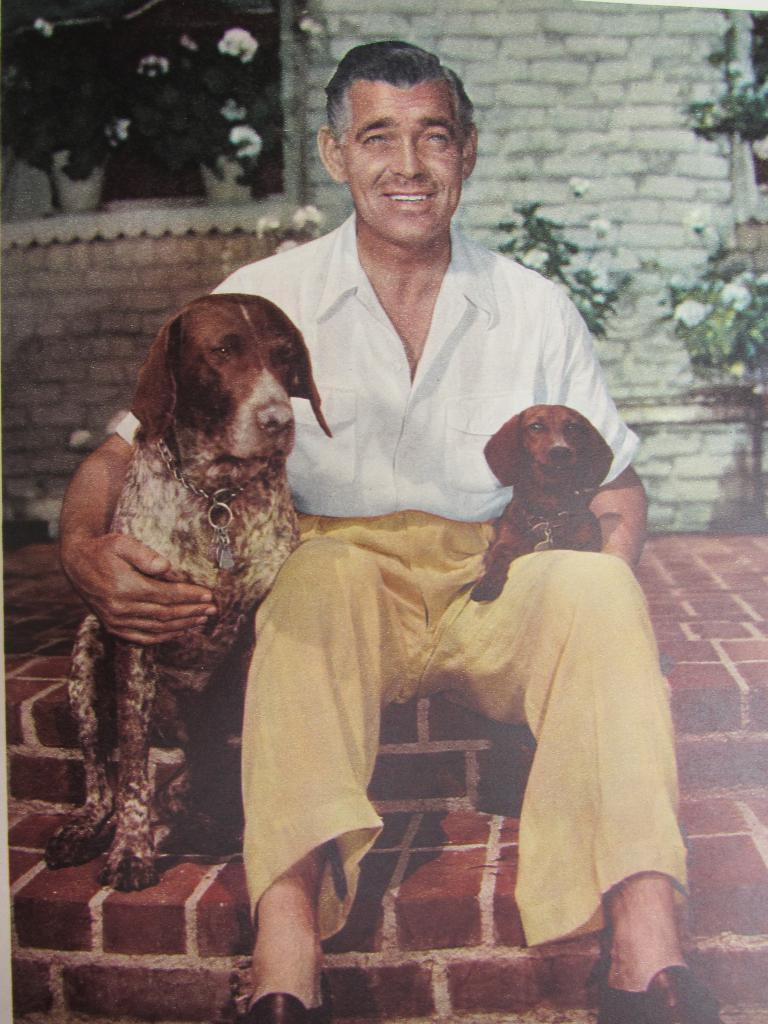What is the man in the image doing? The man is sitting in the image. What is the man holding in the image? The man is holding two dogs, one on each side. What is located behind the man in the image? There is a wall behind the man. What type of vegetation can be seen in the image? There are plants visible in the image. What type of vessel is the man using to transport the corn in the image? There is no vessel or corn present in the image. 